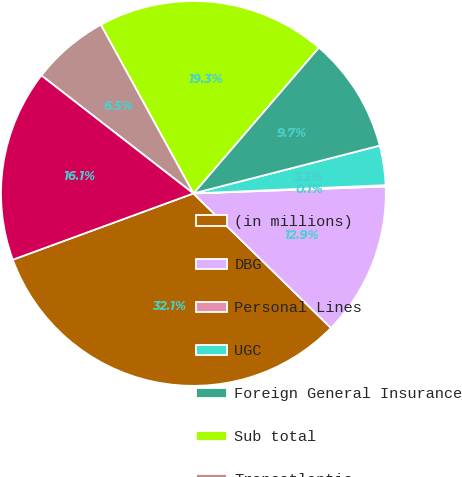Convert chart. <chart><loc_0><loc_0><loc_500><loc_500><pie_chart><fcel>(in millions)<fcel>DBG<fcel>Personal Lines<fcel>UGC<fcel>Foreign General Insurance<fcel>Sub total<fcel>Transatlantic<fcel>Prior years other than<nl><fcel>32.08%<fcel>12.9%<fcel>0.11%<fcel>3.31%<fcel>9.7%<fcel>19.29%<fcel>6.51%<fcel>16.1%<nl></chart> 